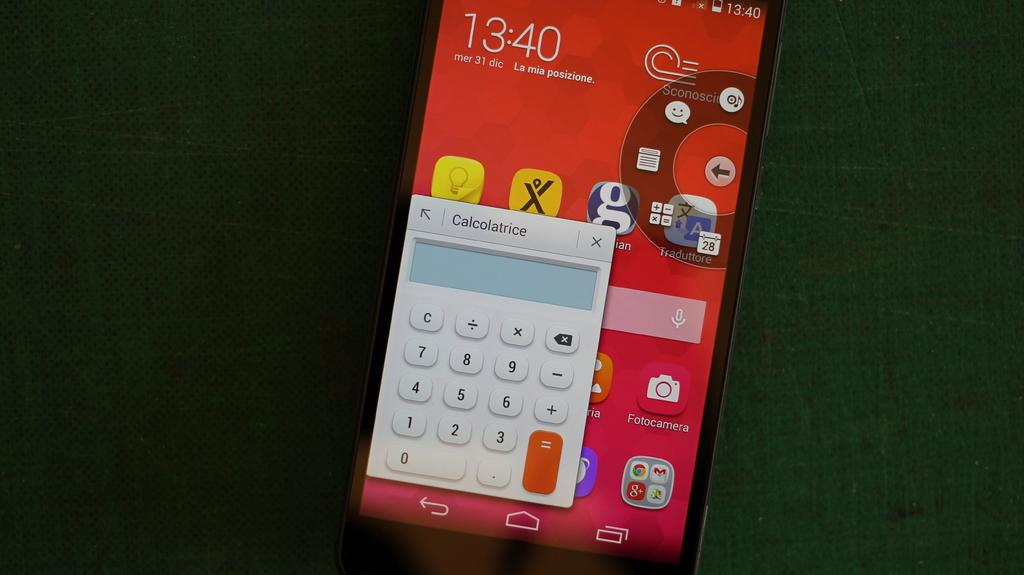<image>
Give a short and clear explanation of the subsequent image. A cellphone screen shows a app called, "calcolatrice." 